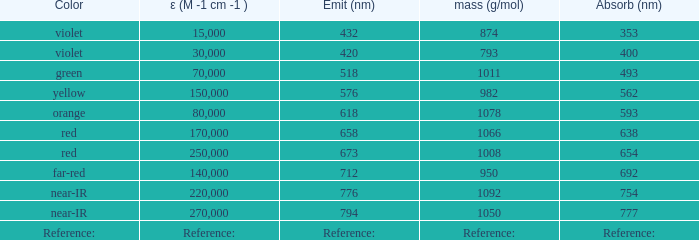Which ε (M -1 cm -1) has a molar mass of 1008 g/mol? 250000.0. 